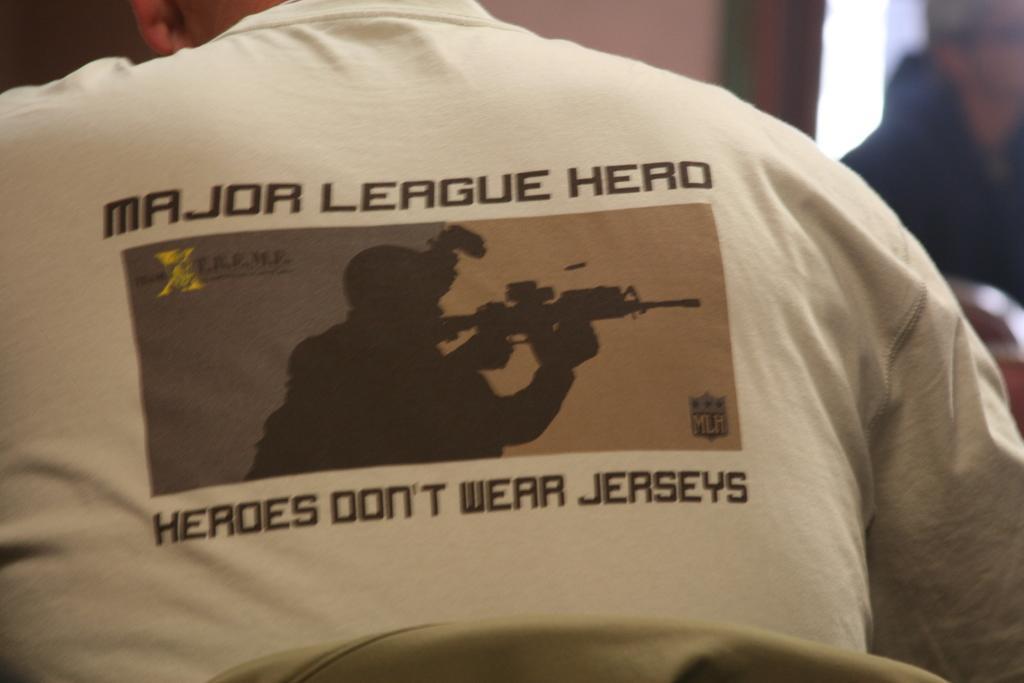Please provide a concise description of this image. In this image we can see a person wearing t shirt with some text on it. In the background we can see a person. 